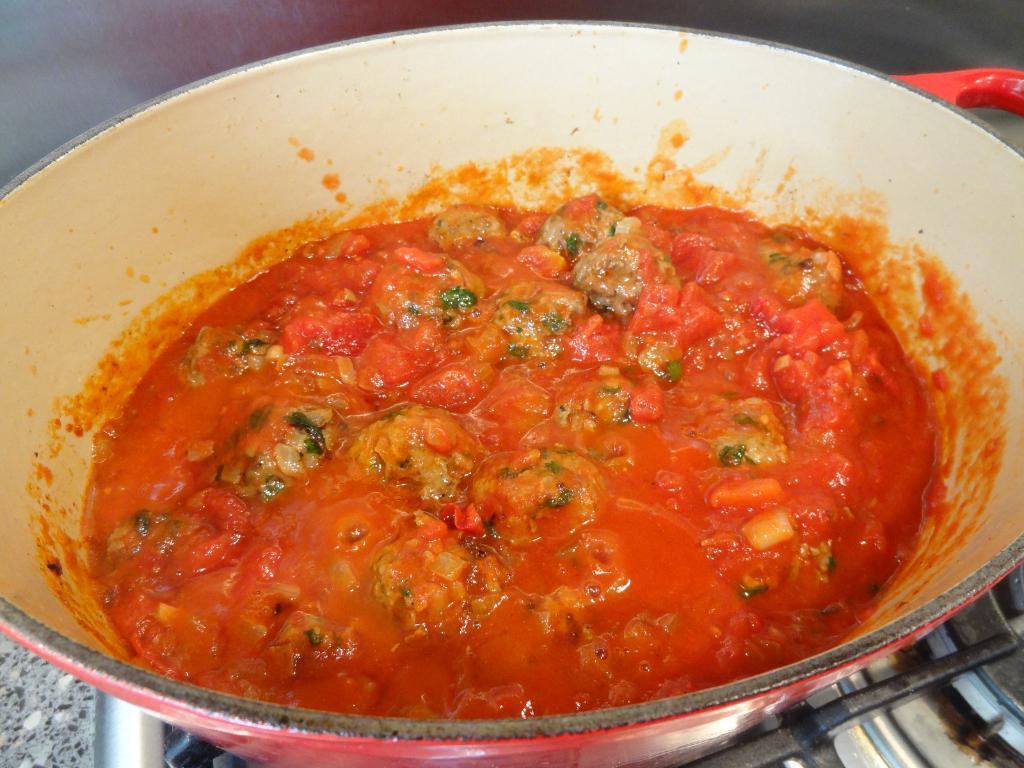Please provide a concise description of this image. In this image, we can see a food item in a bowl and the bowl is placed on the gas stove. 